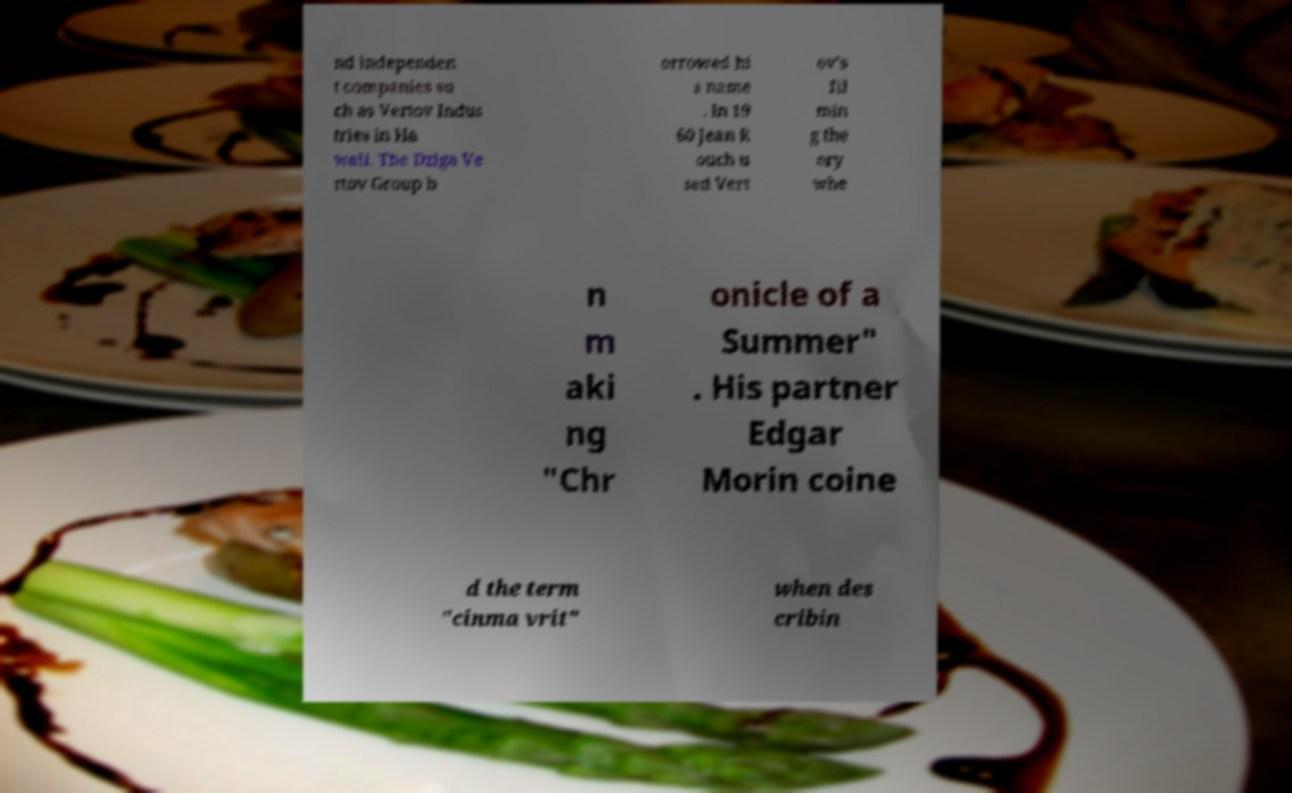Please identify and transcribe the text found in this image. nd independen t companies su ch as Vertov Indus tries in Ha waii. The Dziga Ve rtov Group b orrowed hi s name . In 19 60 Jean R ouch u sed Vert ov's fil min g the ory whe n m aki ng "Chr onicle of a Summer" . His partner Edgar Morin coine d the term "cinma vrit" when des cribin 